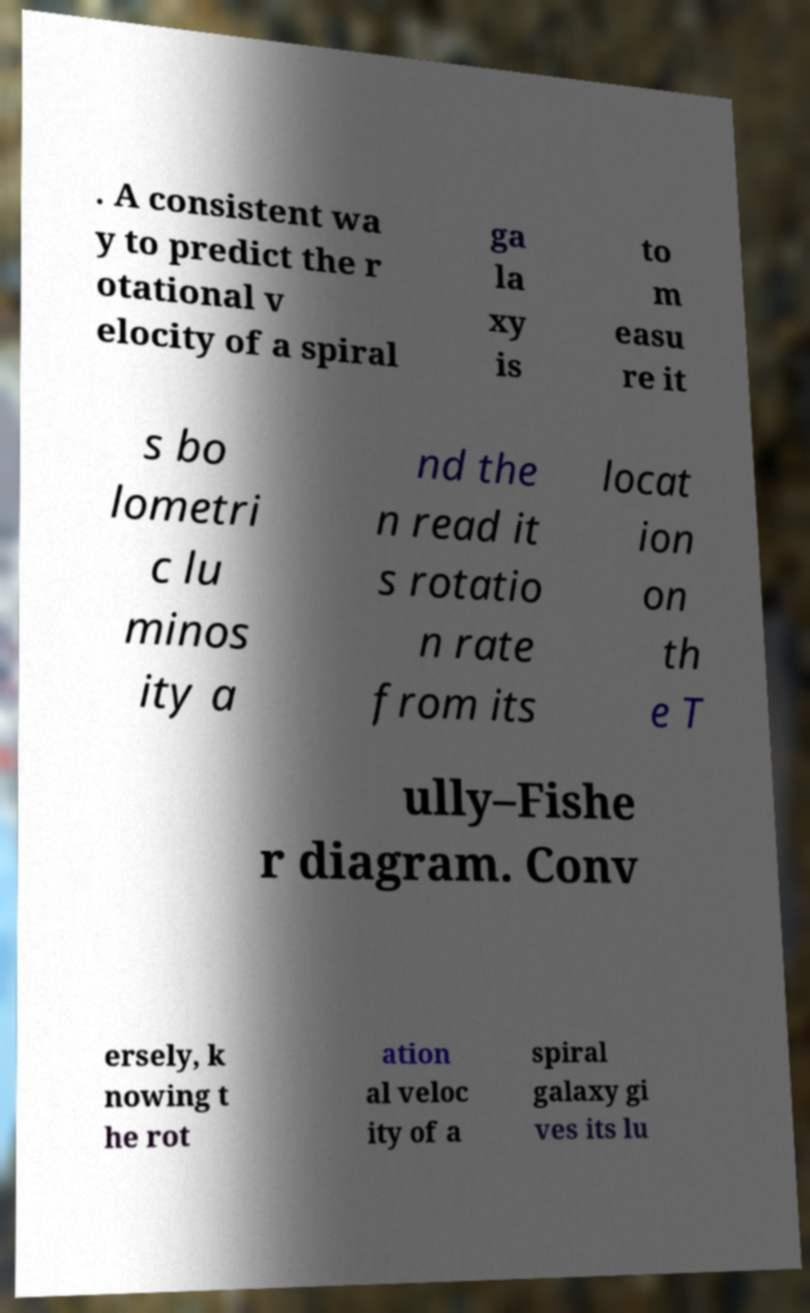There's text embedded in this image that I need extracted. Can you transcribe it verbatim? . A consistent wa y to predict the r otational v elocity of a spiral ga la xy is to m easu re it s bo lometri c lu minos ity a nd the n read it s rotatio n rate from its locat ion on th e T ully–Fishe r diagram. Conv ersely, k nowing t he rot ation al veloc ity of a spiral galaxy gi ves its lu 